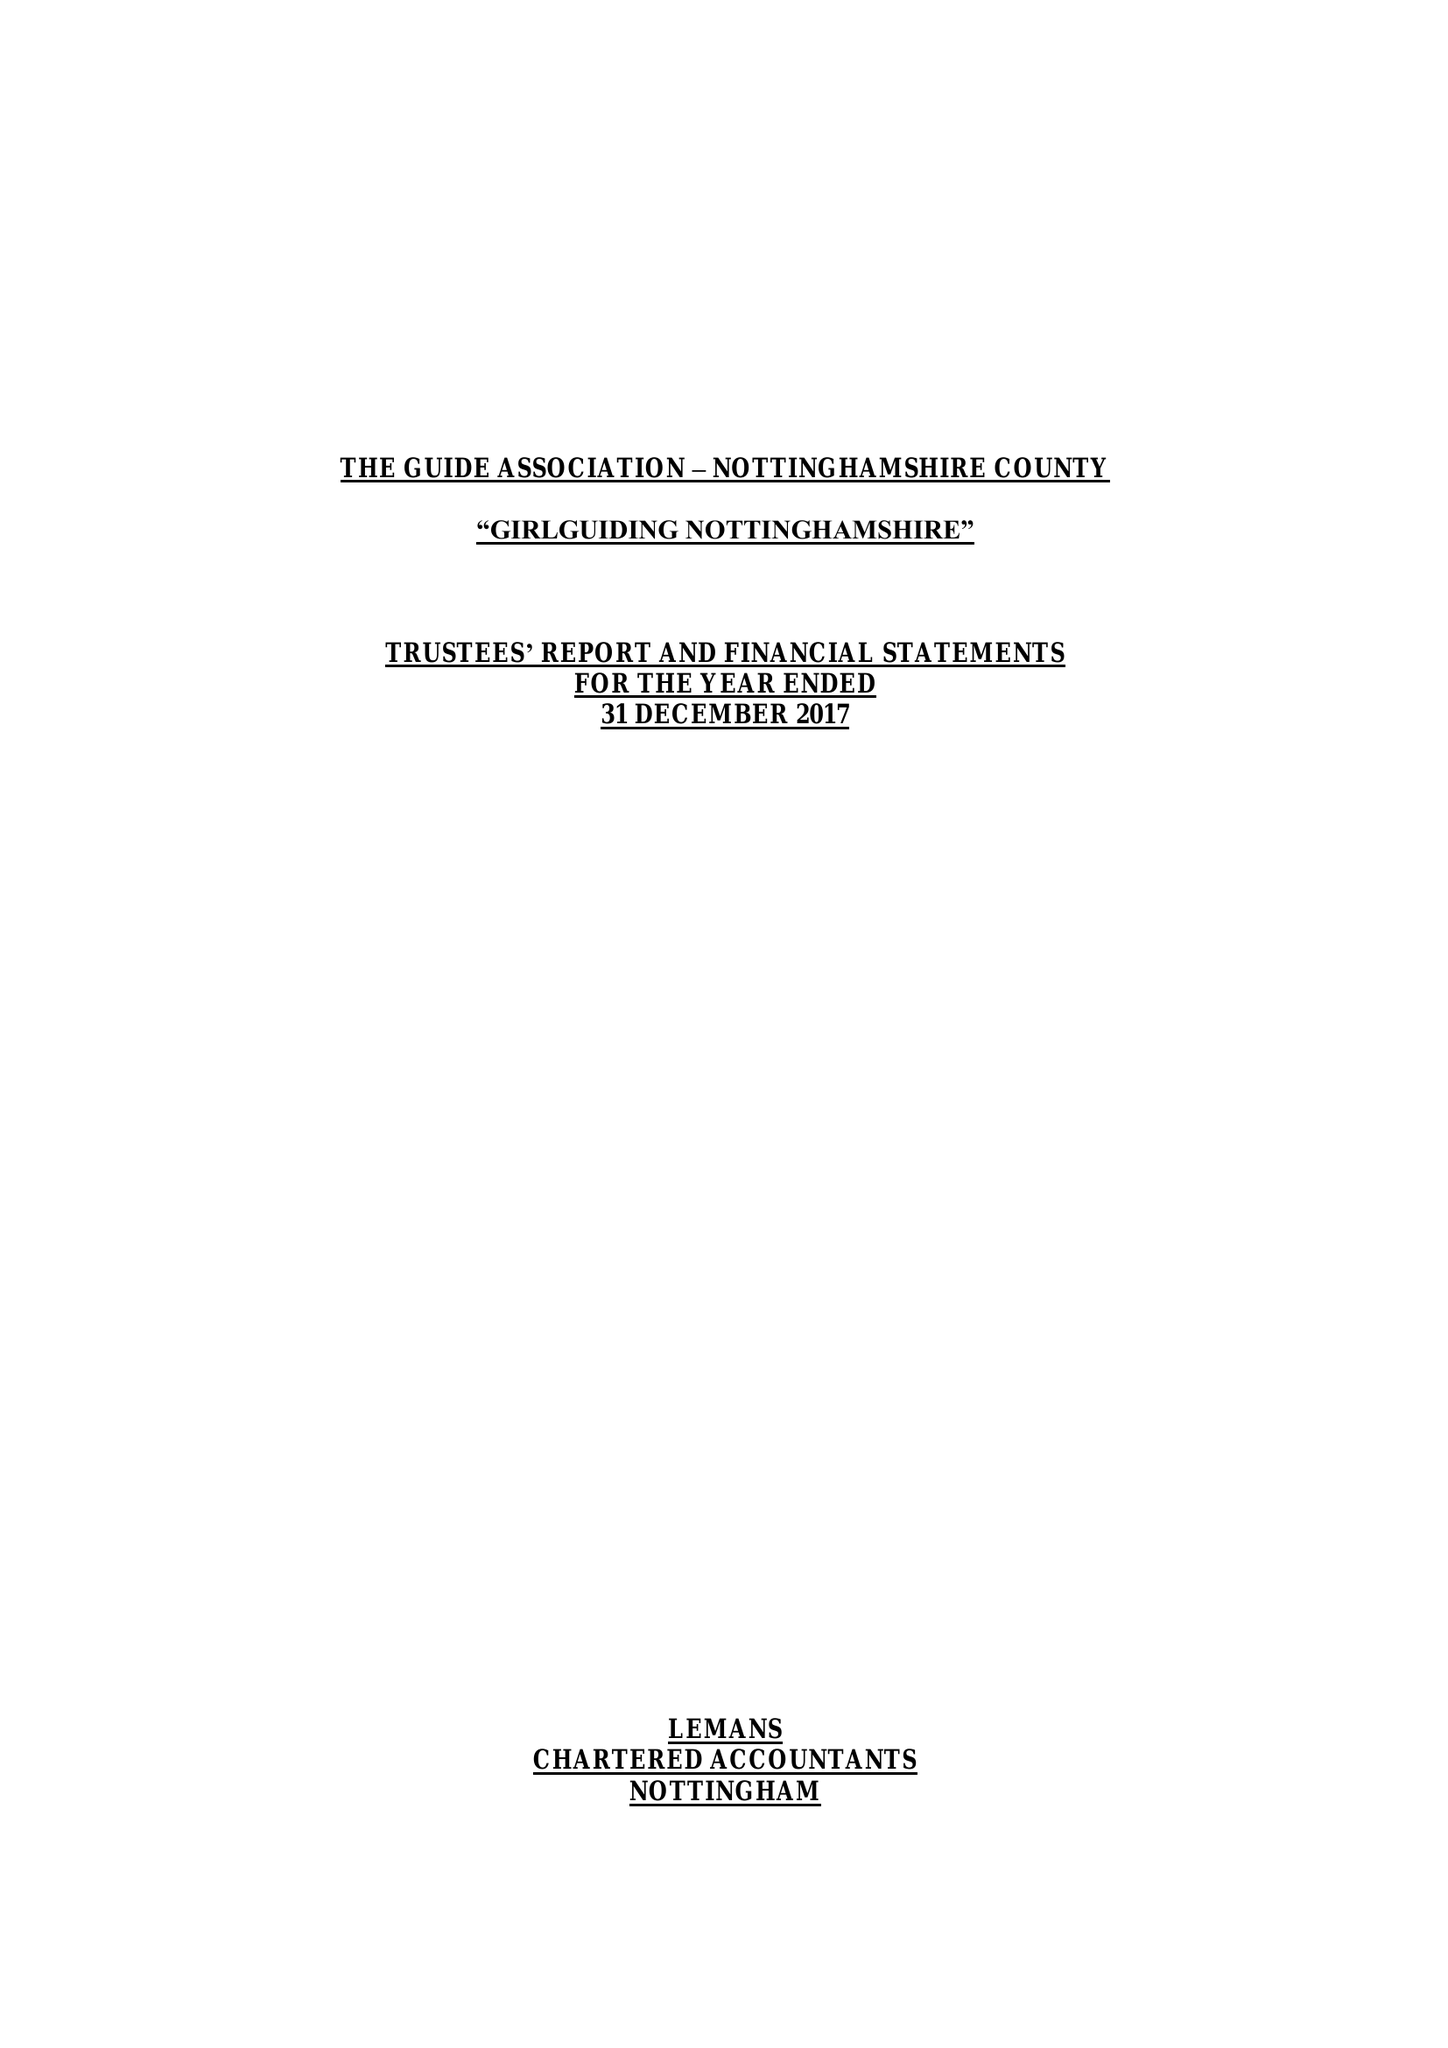What is the value for the income_annually_in_british_pounds?
Answer the question using a single word or phrase. 237734.00 